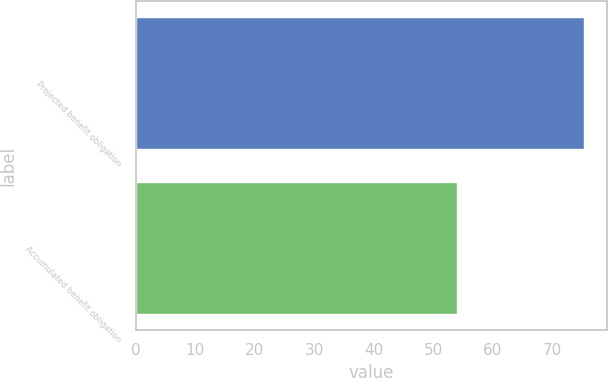Convert chart. <chart><loc_0><loc_0><loc_500><loc_500><bar_chart><fcel>Projected benefit obligation<fcel>Accumulated benefit obligation<nl><fcel>75.3<fcel>53.9<nl></chart> 